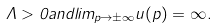Convert formula to latex. <formula><loc_0><loc_0><loc_500><loc_500>\Lambda > 0 a n d l i m _ { p \to \pm \infty } u ( p ) = \infty .</formula> 